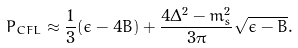Convert formula to latex. <formula><loc_0><loc_0><loc_500><loc_500>P _ { C F L } \approx \frac { 1 } { 3 } ( \epsilon - 4 B ) + \frac { 4 \Delta ^ { 2 } - m _ { s } ^ { 2 } } { 3 \pi } \sqrt { \epsilon - B } .</formula> 